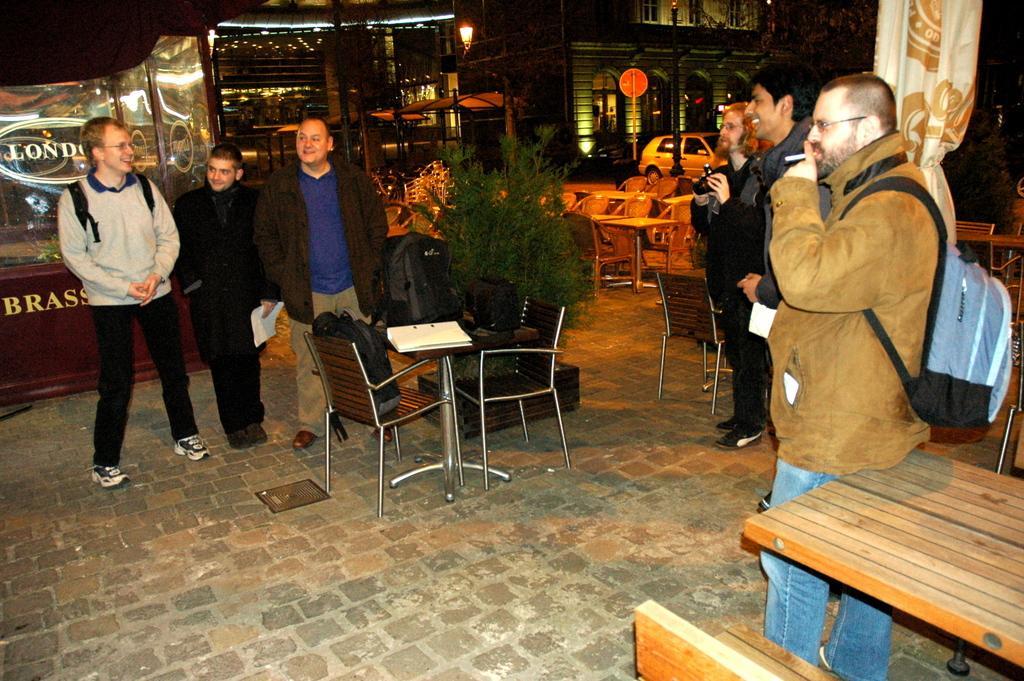Could you give a brief overview of what you see in this image? This is a picture taken in a room, there are a group of people standing on the floor. In front of these people there are chairs, table and bags. The man in black jacket holding a camera. Background of these people is a car and building. 